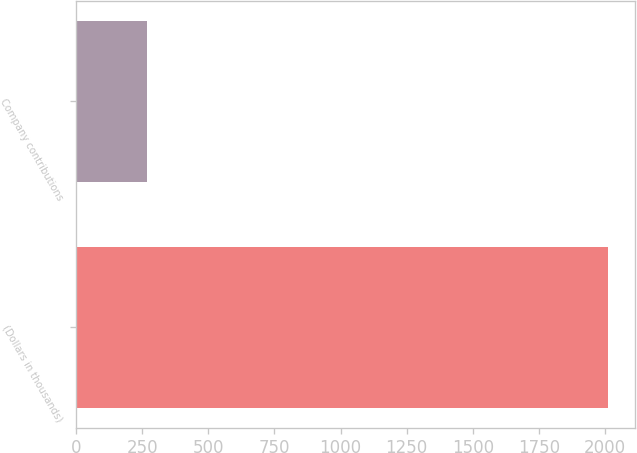<chart> <loc_0><loc_0><loc_500><loc_500><bar_chart><fcel>(Dollars in thousands)<fcel>Company contributions<nl><fcel>2012<fcel>267<nl></chart> 